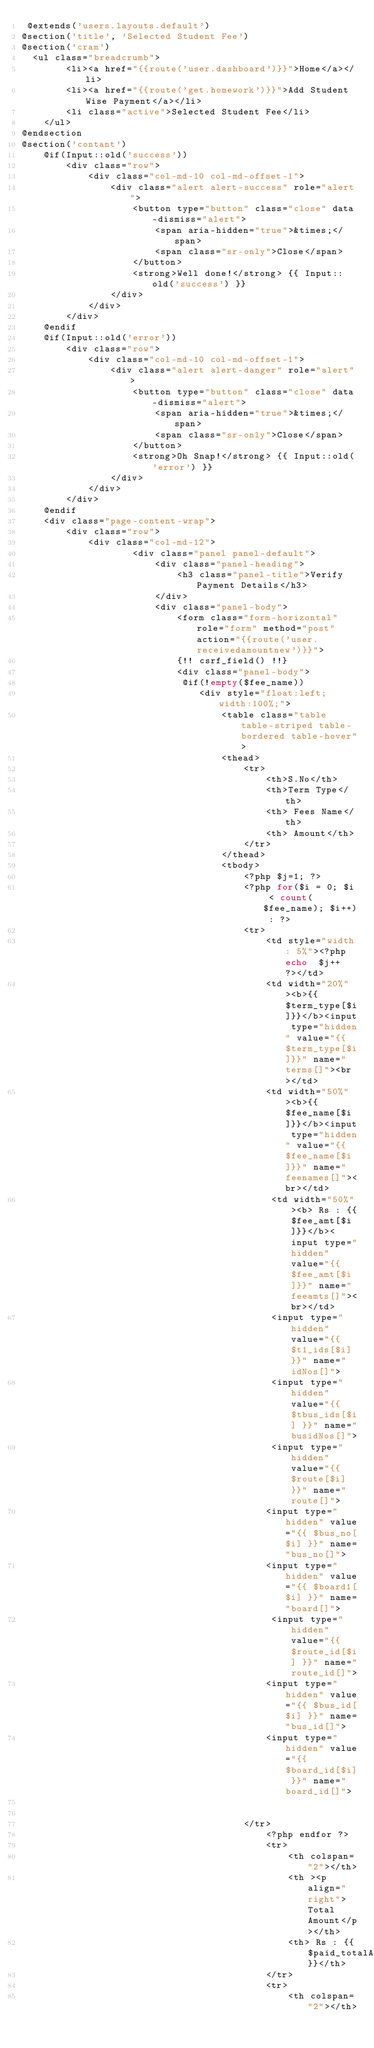<code> <loc_0><loc_0><loc_500><loc_500><_PHP_> @extends('users.layouts.default')
@section('title', 'Selected Student Fee')
@section('cram')
  <ul class="breadcrumb">
        <li><a href="{{route('user.dashboard')}}">Home</a></li>
        <li><a href="{{route('get.homework')}}">Add Student Wise Payment</a></li>
        <li class="active">Selected Student Fee</li>
    </ul>
@endsection
@section('contant')
    @if(Input::old('success'))
        <div class="row">
            <div class="col-md-10 col-md-offset-1">
                <div class="alert alert-success" role="alert">
                    <button type="button" class="close" data-dismiss="alert">
                        <span aria-hidden="true">&times;</span>
                        <span class="sr-only">Close</span>
                    </button>
                    <strong>Well done!</strong> {{ Input::old('success') }}
                </div>
            </div>
        </div>
    @endif
    @if(Input::old('error'))
        <div class="row">
            <div class="col-md-10 col-md-offset-1">
                <div class="alert alert-danger" role="alert">
                    <button type="button" class="close" data-dismiss="alert">
                        <span aria-hidden="true">&times;</span>
                        <span class="sr-only">Close</span>
                    </button>
                    <strong>Oh Snap!</strong> {{ Input::old('error') }}
                </div>
            </div>
        </div>
    @endif
    <div class="page-content-wrap">
        <div class="row">
            <div class="col-md-12">
                    <div class="panel panel-default">
                        <div class="panel-heading">
                            <h3 class="panel-title">Verify Payment Details</h3>
                        </div>
                        <div class="panel-body">
                            <form class="form-horizontal" role="form" method="post" action="{{route('user.receivedamountnew')}}">
                            {!! csrf_field() !!}
                            <div class="panel-body">
                             @if(!empty($fee_name))
                                <div style="float:left; width:100%;">
                                    <table class="table table-striped table-bordered table-hover">
                                    <thead>
                                        <tr>
                                            <th>S.No</th>
                                            <th>Term Type</th>
                                            <th> Fees Name</th>
                                            <th> Amount</th>
                                        </tr>
                                    </thead>
                                    <tbody>
                                        <?php $j=1; ?>
                                        <?php for($i = 0; $i < count($fee_name); $i++) : ?>
                                        <tr>
                                            <td style="width: 5%"><?php echo  $j++ ?></td> 
                                            <td width="20%"><b>{{$term_type[$i]}}</b><input type="hidden" value="{{$term_type[$i]}}" name="terms[]"><br></td>  
                                            <td width="50%"><b>{{$fee_name[$i]}}</b><input type="hidden" value="{{$fee_name[$i]}}" name="feenames[]"><br></td> 
                                             <td width="50%"><b> Rs : {{$fee_amt[$i]}}</b><input type="hidden" value="{{$fee_amt[$i]}}" name="feeamts[]"><br></td> 
                                             <input type="hidden" value="{{ $t1_ids[$i] }}" name="idNos[]">
                                             <input type="hidden" value="{{ $tbus_ids[$i] }}" name="busidNos[]">
                                             <input type="hidden" value="{{ $route[$i] }}" name="route[]">
                                            <input type="hidden" value="{{ $bus_no[$i] }}" name="bus_no[]">
                                            <input type="hidden" value="{{ $board1[$i] }}" name="board[]">
                                             <input type="hidden" value="{{ $route_id[$i] }}" name="route_id[]">
                                            <input type="hidden" value="{{ $bus_id[$i] }}" name="bus_id[]">
                                            <input type="hidden" value="{{ $board_id[$i] }}" name="board_id[]">
                                            
                                             
                                        </tr>
                                            <?php endfor ?>
                                            <tr>
                                                <th colspan="2"></th>
                                                <th ><p align="right">Total Amount</p></th>
                                                <th> Rs : {{$paid_totalAmt}}</th>
                                            </tr>
                                            <tr>
                                                <th colspan="2"></th></code> 